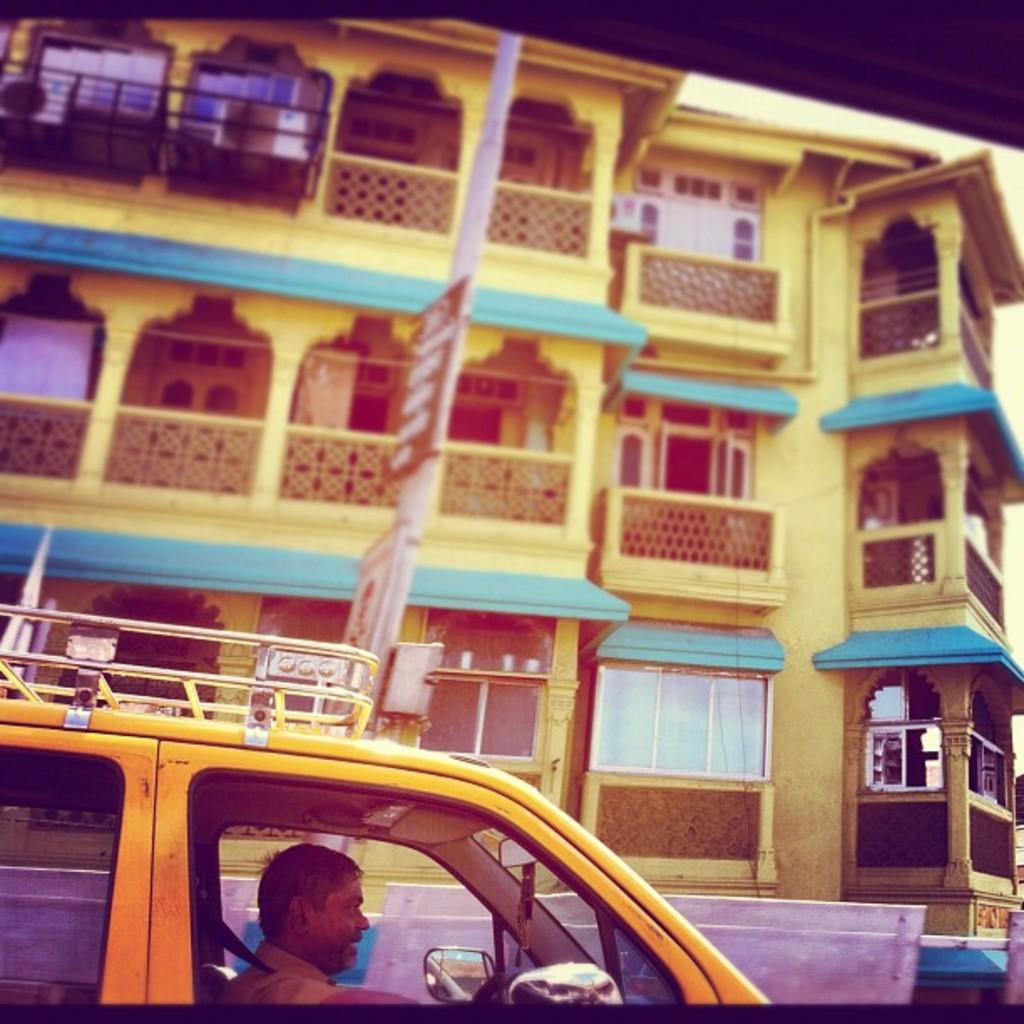What is inside the vehicle in the image? There is a man inside the vehicle in the image. What object can be seen reflecting the surroundings in the image? There is a mirror in the image. What type of structure is visible in the image? There is a building visible in the image. What feature allows access to the vehicle in the image? There is a door in the image. What allows light and air to enter the vehicle in the image? There is a window in the image. What type of scissors can be seen cutting the snow in the image? There is no snow or scissors present in the image. 